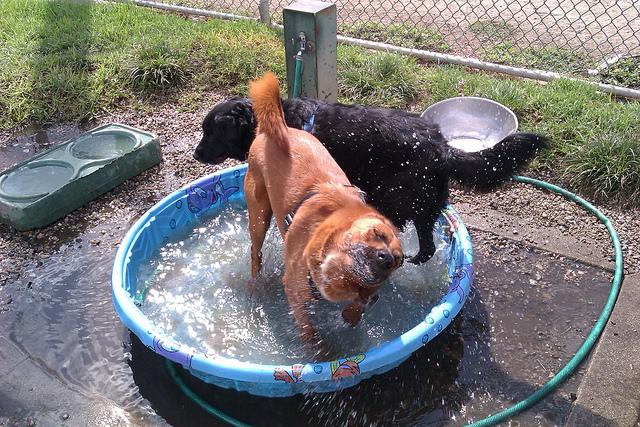What is cast?
Be succinct. Water. Are both dogs wet?
Answer briefly. Yes. What are the dogs standing in?
Answer briefly. Pool. 